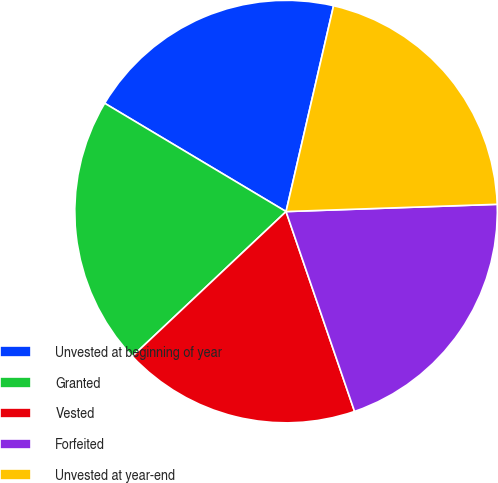Convert chart to OTSL. <chart><loc_0><loc_0><loc_500><loc_500><pie_chart><fcel>Unvested at beginning of year<fcel>Granted<fcel>Vested<fcel>Forfeited<fcel>Unvested at year-end<nl><fcel>20.04%<fcel>20.59%<fcel>18.23%<fcel>20.29%<fcel>20.84%<nl></chart> 